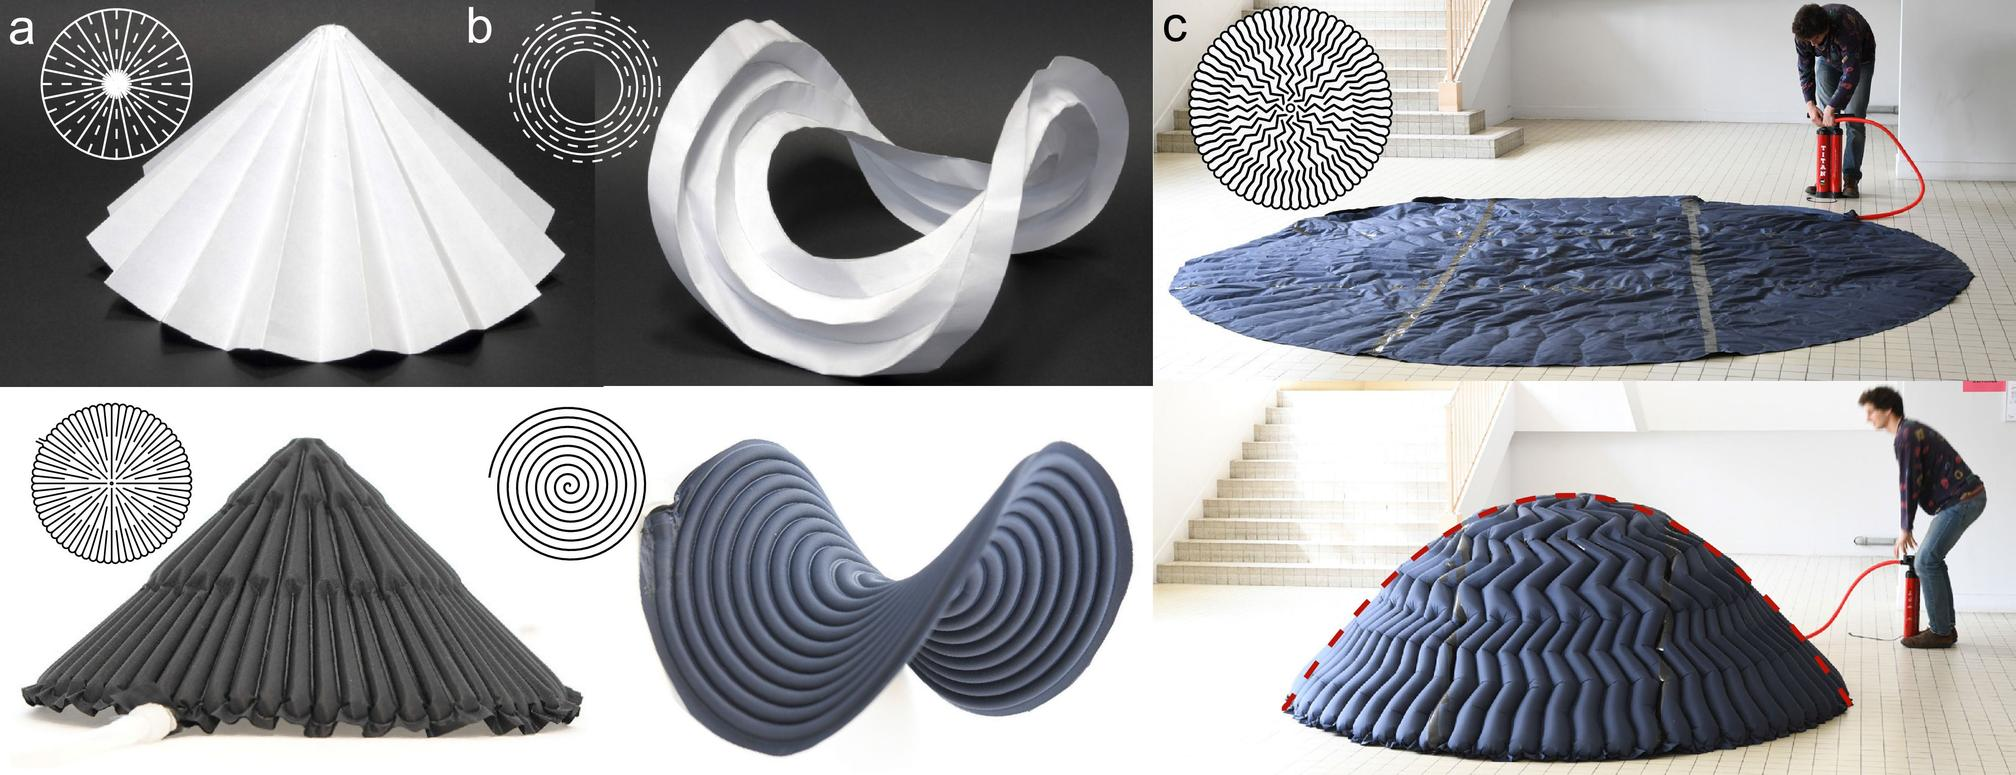What materials are ideal for creating structures like the one shown in figure (a)? Materials ideally suited for creating structures similar to that in figure (a) include paper, thin metal sheets, or lightweight fabric. These materials must be flexible yet able to hold their shape after folding. This ensures they can be manipulated into complex folds without tearing while maintaining the integrity of the structure. 